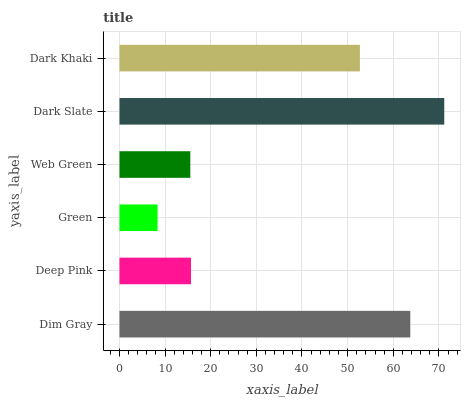Is Green the minimum?
Answer yes or no. Yes. Is Dark Slate the maximum?
Answer yes or no. Yes. Is Deep Pink the minimum?
Answer yes or no. No. Is Deep Pink the maximum?
Answer yes or no. No. Is Dim Gray greater than Deep Pink?
Answer yes or no. Yes. Is Deep Pink less than Dim Gray?
Answer yes or no. Yes. Is Deep Pink greater than Dim Gray?
Answer yes or no. No. Is Dim Gray less than Deep Pink?
Answer yes or no. No. Is Dark Khaki the high median?
Answer yes or no. Yes. Is Deep Pink the low median?
Answer yes or no. Yes. Is Green the high median?
Answer yes or no. No. Is Dark Slate the low median?
Answer yes or no. No. 